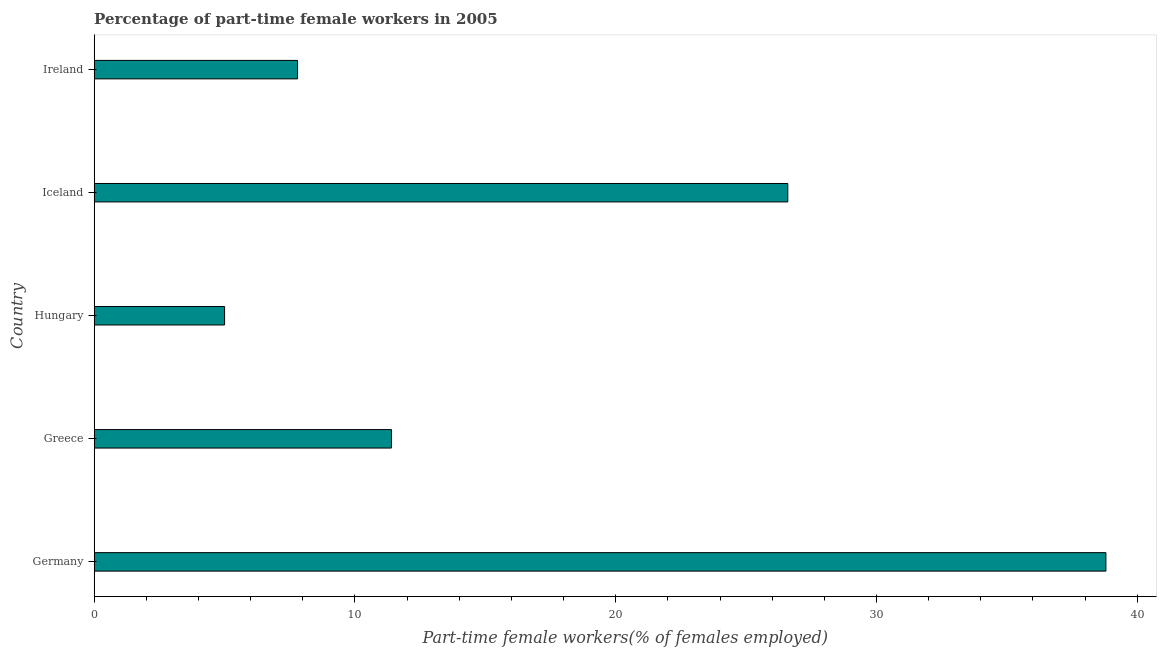Does the graph contain any zero values?
Provide a succinct answer. No. Does the graph contain grids?
Offer a terse response. No. What is the title of the graph?
Offer a terse response. Percentage of part-time female workers in 2005. What is the label or title of the X-axis?
Your answer should be compact. Part-time female workers(% of females employed). What is the percentage of part-time female workers in Ireland?
Give a very brief answer. 7.8. Across all countries, what is the maximum percentage of part-time female workers?
Your answer should be compact. 38.8. In which country was the percentage of part-time female workers maximum?
Your answer should be very brief. Germany. In which country was the percentage of part-time female workers minimum?
Your answer should be compact. Hungary. What is the sum of the percentage of part-time female workers?
Offer a terse response. 89.6. What is the difference between the percentage of part-time female workers in Iceland and Ireland?
Your response must be concise. 18.8. What is the average percentage of part-time female workers per country?
Keep it short and to the point. 17.92. What is the median percentage of part-time female workers?
Your response must be concise. 11.4. What is the ratio of the percentage of part-time female workers in Hungary to that in Iceland?
Your answer should be compact. 0.19. Is the difference between the percentage of part-time female workers in Hungary and Iceland greater than the difference between any two countries?
Provide a short and direct response. No. What is the difference between the highest and the second highest percentage of part-time female workers?
Your answer should be compact. 12.2. What is the difference between the highest and the lowest percentage of part-time female workers?
Your answer should be very brief. 33.8. Are all the bars in the graph horizontal?
Provide a succinct answer. Yes. How many countries are there in the graph?
Your answer should be compact. 5. What is the difference between two consecutive major ticks on the X-axis?
Ensure brevity in your answer.  10. What is the Part-time female workers(% of females employed) of Germany?
Ensure brevity in your answer.  38.8. What is the Part-time female workers(% of females employed) in Greece?
Keep it short and to the point. 11.4. What is the Part-time female workers(% of females employed) of Iceland?
Offer a very short reply. 26.6. What is the Part-time female workers(% of females employed) of Ireland?
Offer a very short reply. 7.8. What is the difference between the Part-time female workers(% of females employed) in Germany and Greece?
Provide a succinct answer. 27.4. What is the difference between the Part-time female workers(% of females employed) in Germany and Hungary?
Ensure brevity in your answer.  33.8. What is the difference between the Part-time female workers(% of females employed) in Greece and Hungary?
Make the answer very short. 6.4. What is the difference between the Part-time female workers(% of females employed) in Greece and Iceland?
Provide a succinct answer. -15.2. What is the difference between the Part-time female workers(% of females employed) in Greece and Ireland?
Offer a terse response. 3.6. What is the difference between the Part-time female workers(% of females employed) in Hungary and Iceland?
Offer a terse response. -21.6. What is the difference between the Part-time female workers(% of females employed) in Iceland and Ireland?
Offer a very short reply. 18.8. What is the ratio of the Part-time female workers(% of females employed) in Germany to that in Greece?
Keep it short and to the point. 3.4. What is the ratio of the Part-time female workers(% of females employed) in Germany to that in Hungary?
Keep it short and to the point. 7.76. What is the ratio of the Part-time female workers(% of females employed) in Germany to that in Iceland?
Offer a terse response. 1.46. What is the ratio of the Part-time female workers(% of females employed) in Germany to that in Ireland?
Your response must be concise. 4.97. What is the ratio of the Part-time female workers(% of females employed) in Greece to that in Hungary?
Ensure brevity in your answer.  2.28. What is the ratio of the Part-time female workers(% of females employed) in Greece to that in Iceland?
Your answer should be compact. 0.43. What is the ratio of the Part-time female workers(% of females employed) in Greece to that in Ireland?
Keep it short and to the point. 1.46. What is the ratio of the Part-time female workers(% of females employed) in Hungary to that in Iceland?
Your response must be concise. 0.19. What is the ratio of the Part-time female workers(% of females employed) in Hungary to that in Ireland?
Offer a terse response. 0.64. What is the ratio of the Part-time female workers(% of females employed) in Iceland to that in Ireland?
Provide a succinct answer. 3.41. 